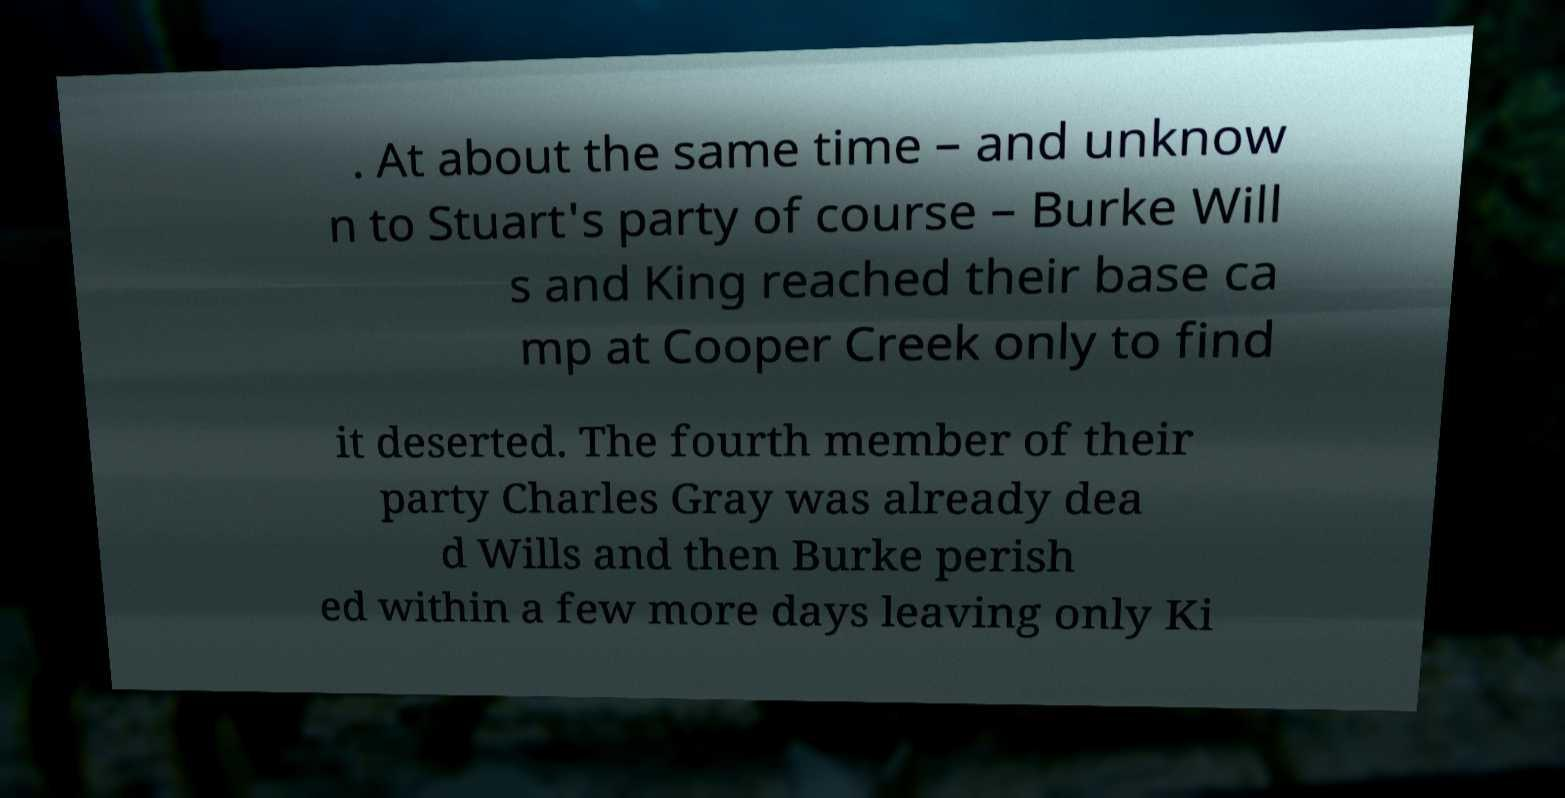For documentation purposes, I need the text within this image transcribed. Could you provide that? . At about the same time – and unknow n to Stuart's party of course – Burke Will s and King reached their base ca mp at Cooper Creek only to find it deserted. The fourth member of their party Charles Gray was already dea d Wills and then Burke perish ed within a few more days leaving only Ki 